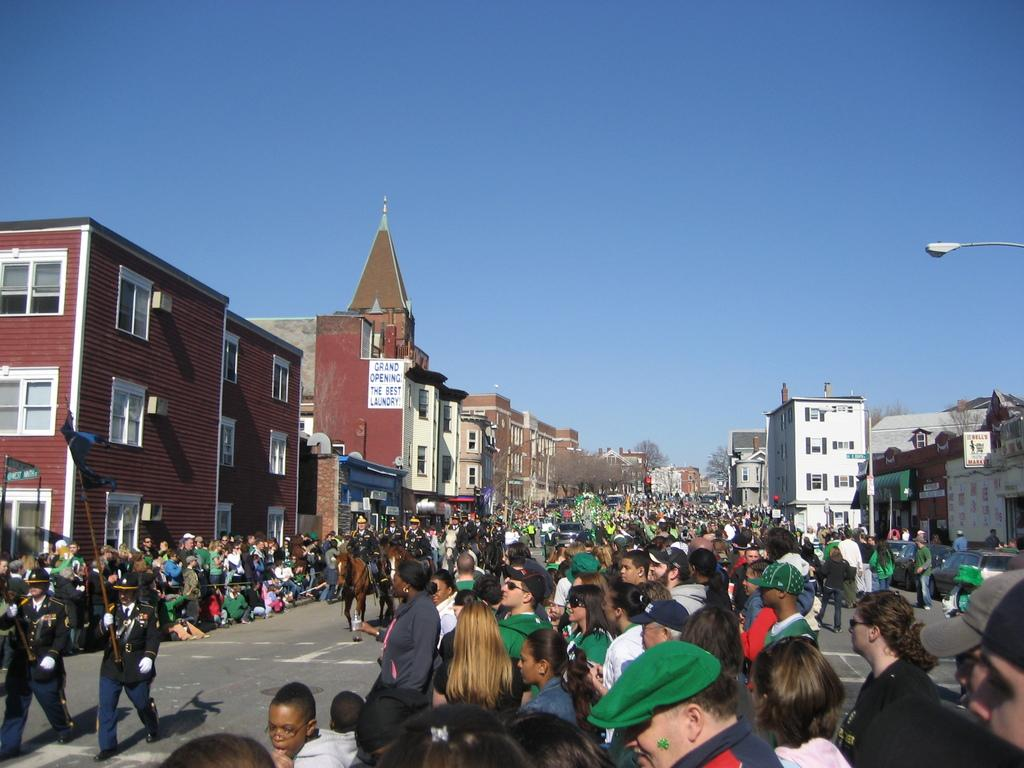Who or what can be seen in the image? There are people in the image. What type of structures are visible in the image? There are buildings in the image. What is the surface that the people and buildings are standing on? The ground is visible in the image. What are the poles with text used for in the image? The poles with text are likely used for signage or advertisements. What type of vegetation is present in the image? There are trees in the image. What other objects can be seen flying in the image? There are flags in the image. What part of the natural environment is visible in the image? The sky is visible in the image. Can you see any legs of the people in the image? The image does not show the legs of the people; it only shows their upper bodies. Is there a playground visible in the image? There is no playground present in the image. What type of fruit is being eaten by the people in the image? There is no fruit, including grapes, visible in the image. 